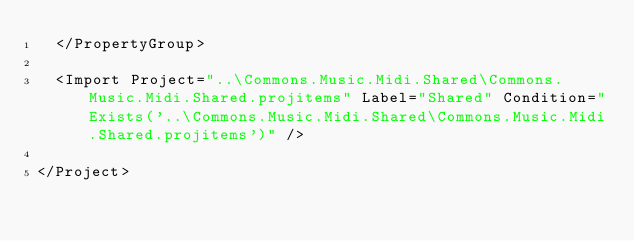Convert code to text. <code><loc_0><loc_0><loc_500><loc_500><_XML_>  </PropertyGroup>

  <Import Project="..\Commons.Music.Midi.Shared\Commons.Music.Midi.Shared.projitems" Label="Shared" Condition="Exists('..\Commons.Music.Midi.Shared\Commons.Music.Midi.Shared.projitems')" />

</Project>
</code> 